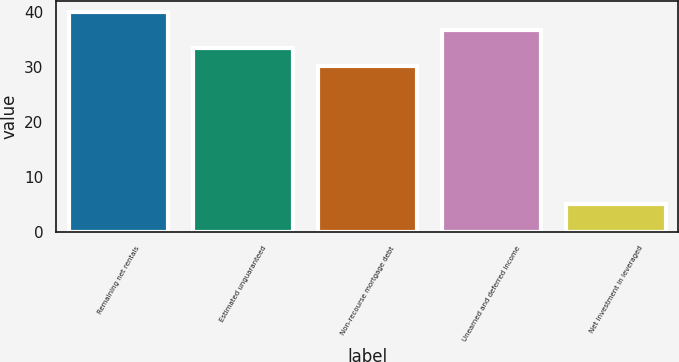Convert chart. <chart><loc_0><loc_0><loc_500><loc_500><bar_chart><fcel>Remaining net rentals<fcel>Estimated unguaranteed<fcel>Non-recourse mortgage debt<fcel>Unearned and deferred income<fcel>Net investment in leveraged<nl><fcel>39.88<fcel>33.36<fcel>30.1<fcel>36.62<fcel>5<nl></chart> 